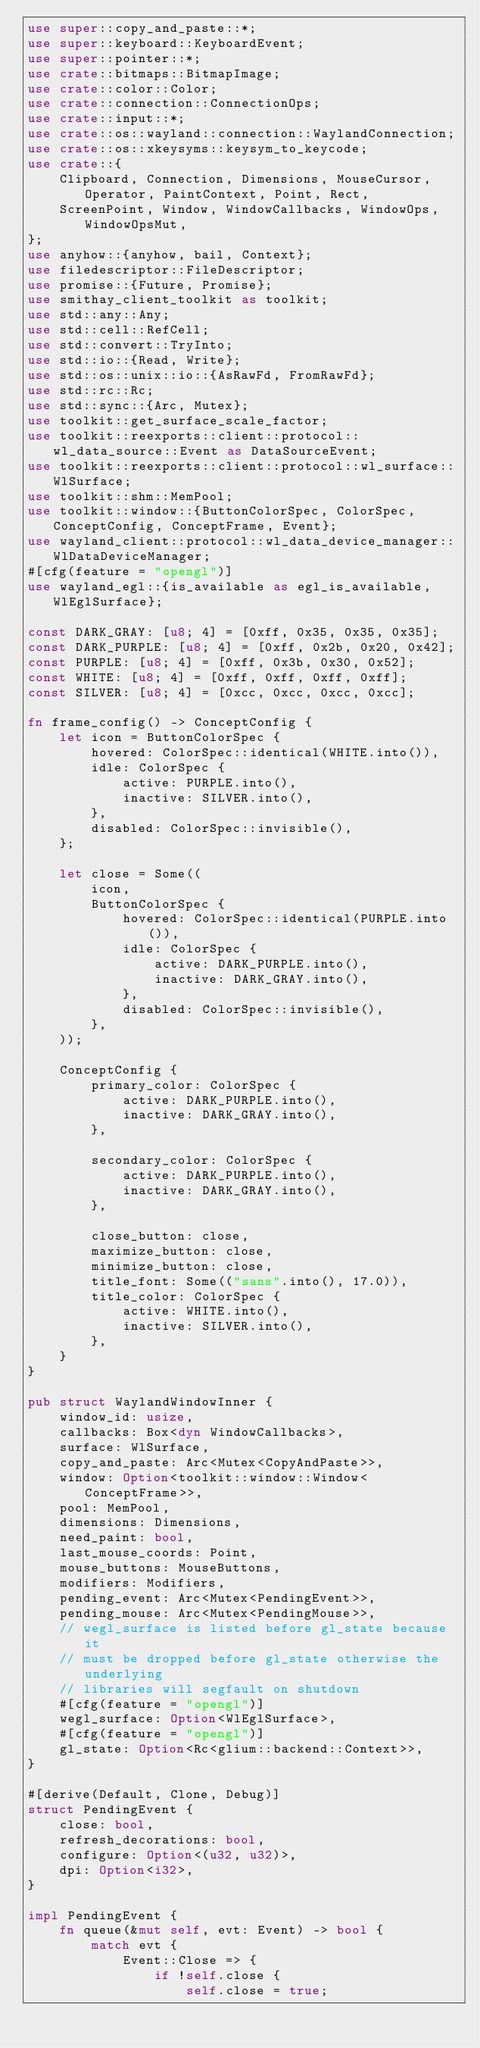Convert code to text. <code><loc_0><loc_0><loc_500><loc_500><_Rust_>use super::copy_and_paste::*;
use super::keyboard::KeyboardEvent;
use super::pointer::*;
use crate::bitmaps::BitmapImage;
use crate::color::Color;
use crate::connection::ConnectionOps;
use crate::input::*;
use crate::os::wayland::connection::WaylandConnection;
use crate::os::xkeysyms::keysym_to_keycode;
use crate::{
    Clipboard, Connection, Dimensions, MouseCursor, Operator, PaintContext, Point, Rect,
    ScreenPoint, Window, WindowCallbacks, WindowOps, WindowOpsMut,
};
use anyhow::{anyhow, bail, Context};
use filedescriptor::FileDescriptor;
use promise::{Future, Promise};
use smithay_client_toolkit as toolkit;
use std::any::Any;
use std::cell::RefCell;
use std::convert::TryInto;
use std::io::{Read, Write};
use std::os::unix::io::{AsRawFd, FromRawFd};
use std::rc::Rc;
use std::sync::{Arc, Mutex};
use toolkit::get_surface_scale_factor;
use toolkit::reexports::client::protocol::wl_data_source::Event as DataSourceEvent;
use toolkit::reexports::client::protocol::wl_surface::WlSurface;
use toolkit::shm::MemPool;
use toolkit::window::{ButtonColorSpec, ColorSpec, ConceptConfig, ConceptFrame, Event};
use wayland_client::protocol::wl_data_device_manager::WlDataDeviceManager;
#[cfg(feature = "opengl")]
use wayland_egl::{is_available as egl_is_available, WlEglSurface};

const DARK_GRAY: [u8; 4] = [0xff, 0x35, 0x35, 0x35];
const DARK_PURPLE: [u8; 4] = [0xff, 0x2b, 0x20, 0x42];
const PURPLE: [u8; 4] = [0xff, 0x3b, 0x30, 0x52];
const WHITE: [u8; 4] = [0xff, 0xff, 0xff, 0xff];
const SILVER: [u8; 4] = [0xcc, 0xcc, 0xcc, 0xcc];

fn frame_config() -> ConceptConfig {
    let icon = ButtonColorSpec {
        hovered: ColorSpec::identical(WHITE.into()),
        idle: ColorSpec {
            active: PURPLE.into(),
            inactive: SILVER.into(),
        },
        disabled: ColorSpec::invisible(),
    };

    let close = Some((
        icon,
        ButtonColorSpec {
            hovered: ColorSpec::identical(PURPLE.into()),
            idle: ColorSpec {
                active: DARK_PURPLE.into(),
                inactive: DARK_GRAY.into(),
            },
            disabled: ColorSpec::invisible(),
        },
    ));

    ConceptConfig {
        primary_color: ColorSpec {
            active: DARK_PURPLE.into(),
            inactive: DARK_GRAY.into(),
        },

        secondary_color: ColorSpec {
            active: DARK_PURPLE.into(),
            inactive: DARK_GRAY.into(),
        },

        close_button: close,
        maximize_button: close,
        minimize_button: close,
        title_font: Some(("sans".into(), 17.0)),
        title_color: ColorSpec {
            active: WHITE.into(),
            inactive: SILVER.into(),
        },
    }
}

pub struct WaylandWindowInner {
    window_id: usize,
    callbacks: Box<dyn WindowCallbacks>,
    surface: WlSurface,
    copy_and_paste: Arc<Mutex<CopyAndPaste>>,
    window: Option<toolkit::window::Window<ConceptFrame>>,
    pool: MemPool,
    dimensions: Dimensions,
    need_paint: bool,
    last_mouse_coords: Point,
    mouse_buttons: MouseButtons,
    modifiers: Modifiers,
    pending_event: Arc<Mutex<PendingEvent>>,
    pending_mouse: Arc<Mutex<PendingMouse>>,
    // wegl_surface is listed before gl_state because it
    // must be dropped before gl_state otherwise the underlying
    // libraries will segfault on shutdown
    #[cfg(feature = "opengl")]
    wegl_surface: Option<WlEglSurface>,
    #[cfg(feature = "opengl")]
    gl_state: Option<Rc<glium::backend::Context>>,
}

#[derive(Default, Clone, Debug)]
struct PendingEvent {
    close: bool,
    refresh_decorations: bool,
    configure: Option<(u32, u32)>,
    dpi: Option<i32>,
}

impl PendingEvent {
    fn queue(&mut self, evt: Event) -> bool {
        match evt {
            Event::Close => {
                if !self.close {
                    self.close = true;</code> 